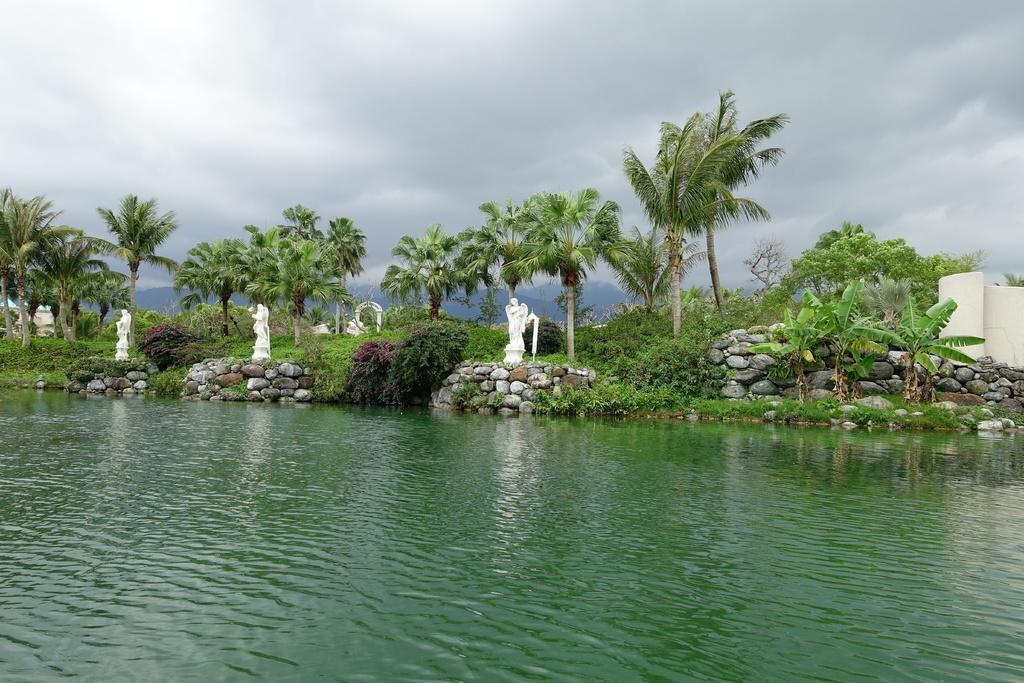Describe this image in one or two sentences. In the image there are many trees and plants in the background with a stone fence in the front and statues behind it, in the front its a pond and above sky with clouds. 